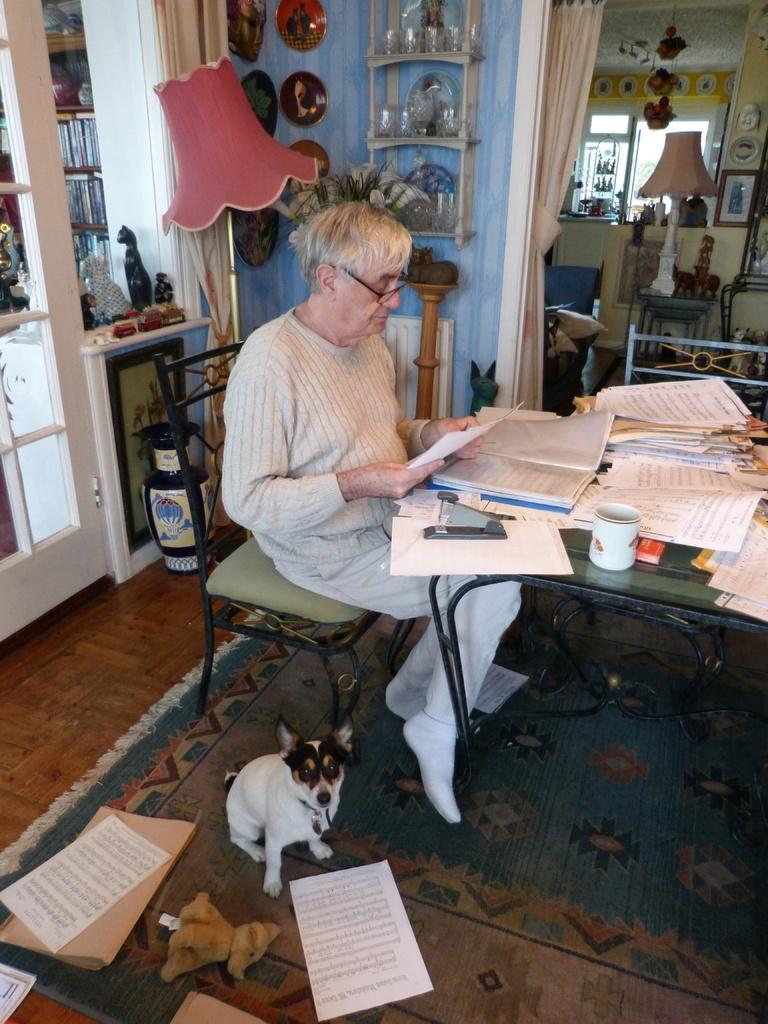Could you give a brief overview of what you see in this image? In the given image we can see a person sitting on a chair. This is a table on which many books and paper are kept. This is a teacup. This is a carpet which is in light orange color, even a dog is sitting on a carpet. This is a light lamp. 